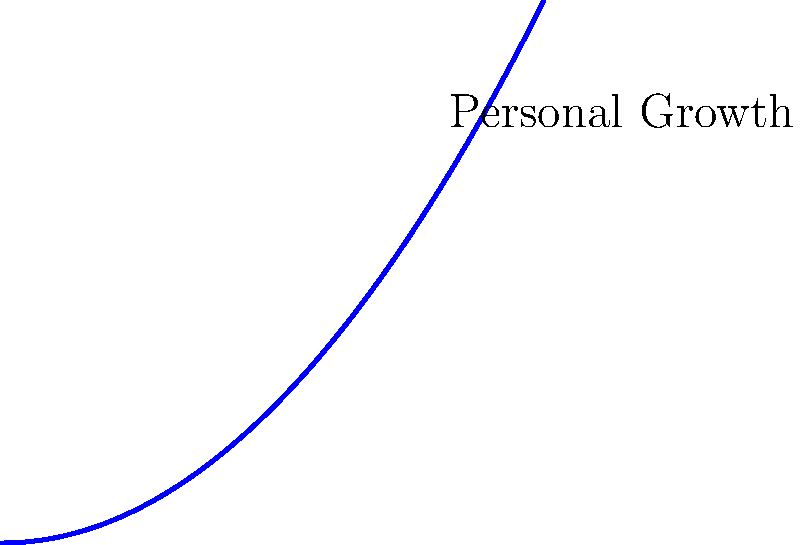In the spiral diagram representing personal growth over time, each milestone $M_i$ represents a significant achievement in your self-improvement journey. If the spiral function is given by $f(x) = 0.1x^2$, at which milestone will you experience the greatest rate of personal growth? To determine the milestone with the greatest rate of personal growth, we need to analyze the rate of change of the function $f(x) = 0.1x^2$. Here's how we can approach this:

1. The rate of change is represented by the derivative of the function. Let's find the derivative:
   $f'(x) = 0.2x$

2. The derivative tells us the instantaneous rate of change at any point on the curve.

3. Now, let's evaluate the derivative at each milestone:
   $M_1: f'(2) = 0.2 \cdot 2 = 0.4$
   $M_2: f'(4) = 0.2 \cdot 4 = 0.8$
   $M_3: f'(6) = 0.2 \cdot 6 = 1.2$
   $M_4: f'(8) = 0.2 \cdot 8 = 1.6$
   $M_5: f'(10) = 0.2 \cdot 10 = 2.0$

4. We can see that the rate of change increases as we move along the spiral.

5. The greatest rate of change occurs at the last visible milestone, $M_5$, where the derivative value is highest at 2.0.

This aligns with the idea in self-help and personal growth that progress often accelerates as we continue our journey, symbolized by the widening turns of the spiral.
Answer: $M_5$ 